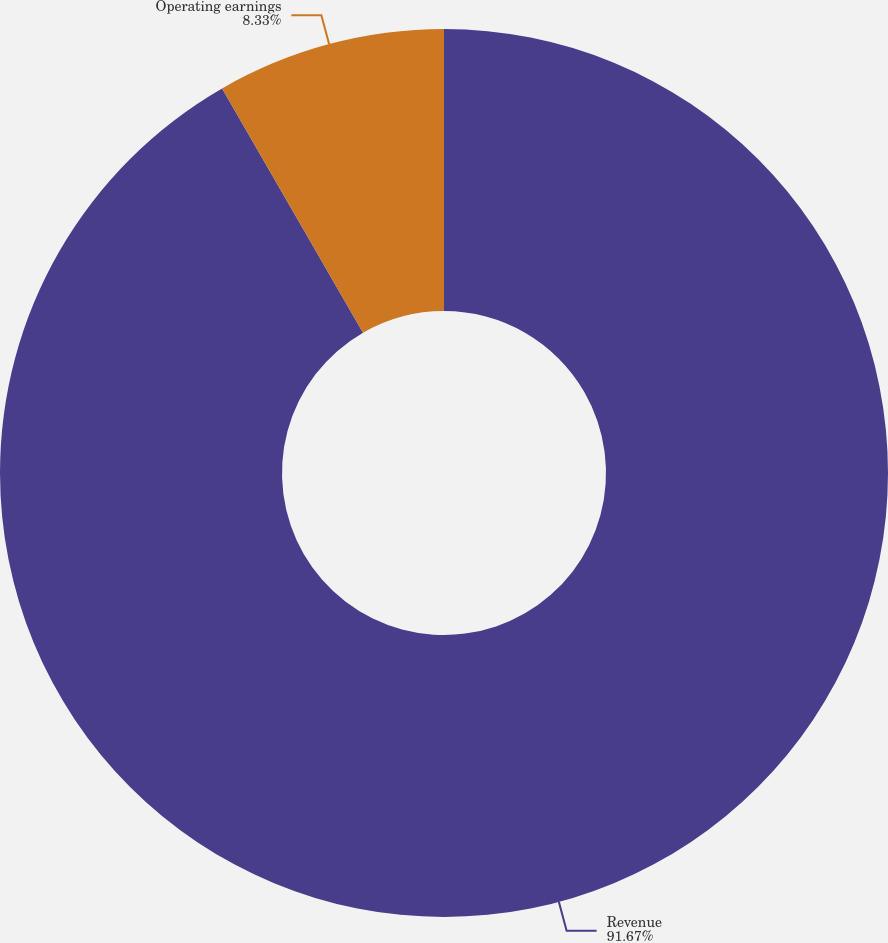Convert chart to OTSL. <chart><loc_0><loc_0><loc_500><loc_500><pie_chart><fcel>Revenue<fcel>Operating earnings<nl><fcel>91.67%<fcel>8.33%<nl></chart> 